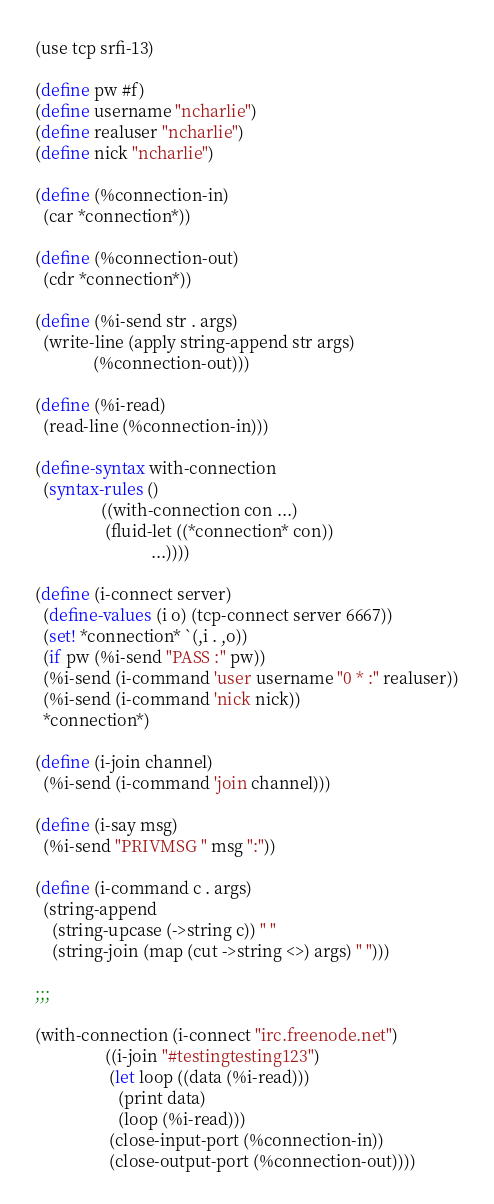Convert code to text. <code><loc_0><loc_0><loc_500><loc_500><_Scheme_>(use tcp srfi-13)

(define pw #f)
(define username "ncharlie")
(define realuser "ncharlie")
(define nick "ncharlie")

(define (%connection-in)
  (car *connection*))

(define (%connection-out)
  (cdr *connection*))

(define (%i-send str . args)
  (write-line (apply string-append str args)
              (%connection-out)))

(define (%i-read)
  (read-line (%connection-in)))

(define-syntax with-connection
  (syntax-rules ()
                ((with-connection con ...)
                 (fluid-let ((*connection* con))
                            ...))))

(define (i-connect server)
  (define-values (i o) (tcp-connect server 6667))
  (set! *connection* `(,i . ,o))
  (if pw (%i-send "PASS :" pw))
  (%i-send (i-command 'user username "0 * :" realuser))
  (%i-send (i-command 'nick nick))
  *connection*)

(define (i-join channel)
  (%i-send (i-command 'join channel)))

(define (i-say msg)
  (%i-send "PRIVMSG " msg ":"))

(define (i-command c . args)
  (string-append
    (string-upcase (->string c)) " "
    (string-join (map (cut ->string <>) args) " ")))

;;;

(with-connection (i-connect "irc.freenode.net")
                 ((i-join "#testingtesting123")
                  (let loop ((data (%i-read)))
                    (print data)
                    (loop (%i-read)))
                  (close-input-port (%connection-in))
                  (close-output-port (%connection-out))))
</code> 